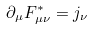Convert formula to latex. <formula><loc_0><loc_0><loc_500><loc_500>\partial _ { \mu } F ^ { * } _ { \mu \nu } = j _ { \nu }</formula> 